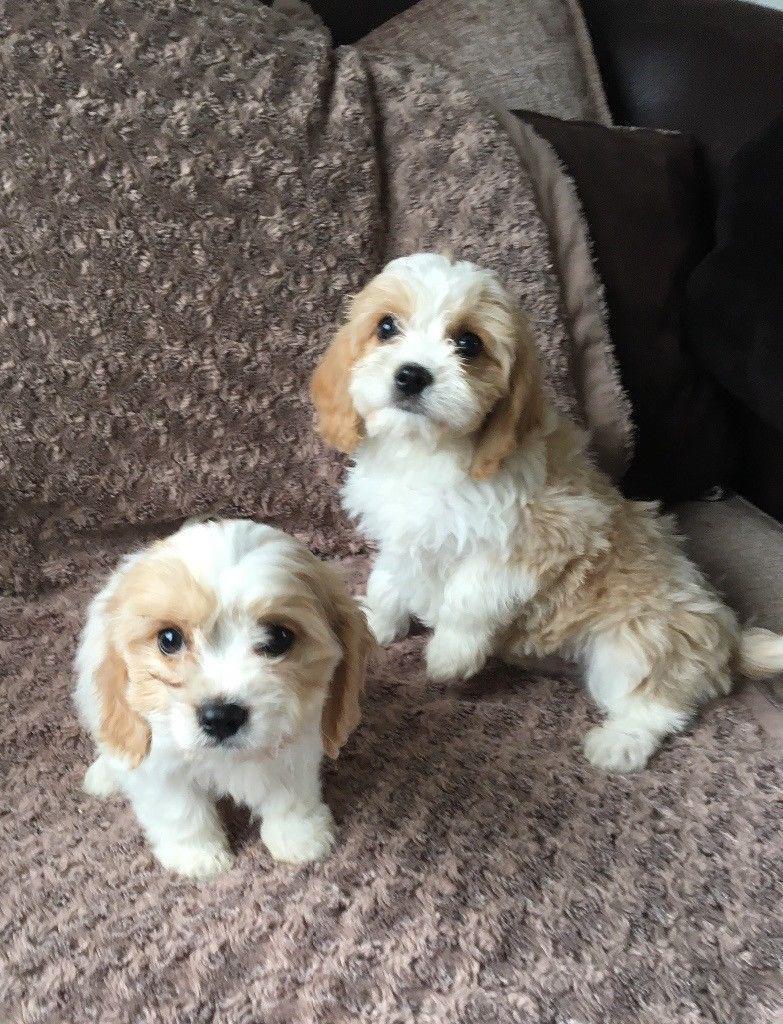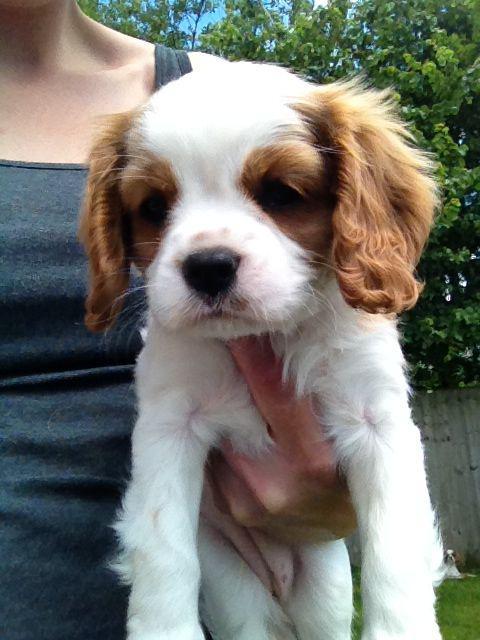The first image is the image on the left, the second image is the image on the right. For the images displayed, is the sentence "One image contains twice as many spaniel pups as the other, and one image includes a hand holding a puppy." factually correct? Answer yes or no. Yes. The first image is the image on the left, the second image is the image on the right. Considering the images on both sides, is "The left image contains exactly two dogs." valid? Answer yes or no. Yes. 